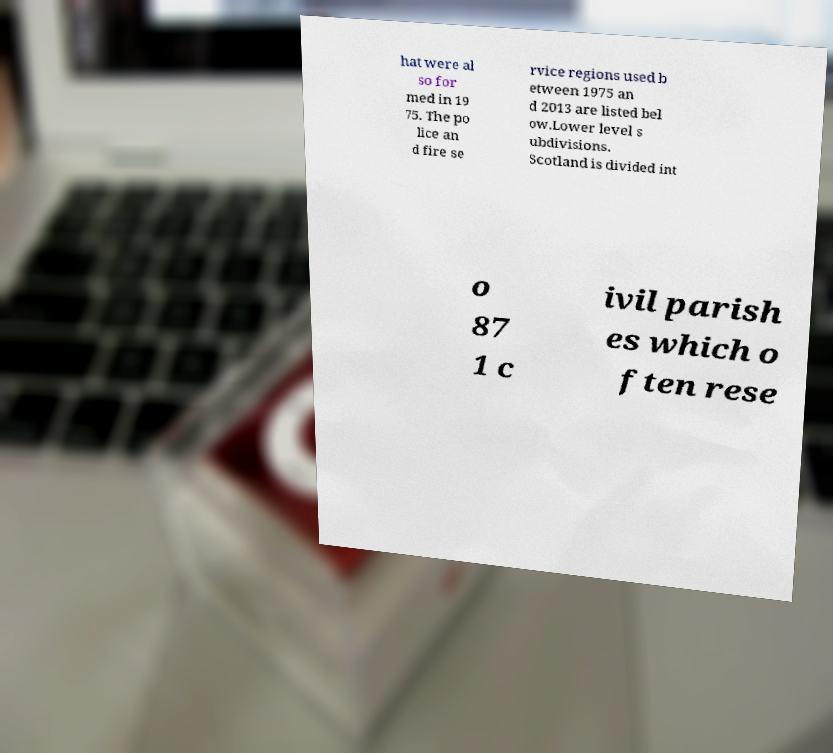Could you assist in decoding the text presented in this image and type it out clearly? hat were al so for med in 19 75. The po lice an d fire se rvice regions used b etween 1975 an d 2013 are listed bel ow.Lower level s ubdivisions. Scotland is divided int o 87 1 c ivil parish es which o ften rese 